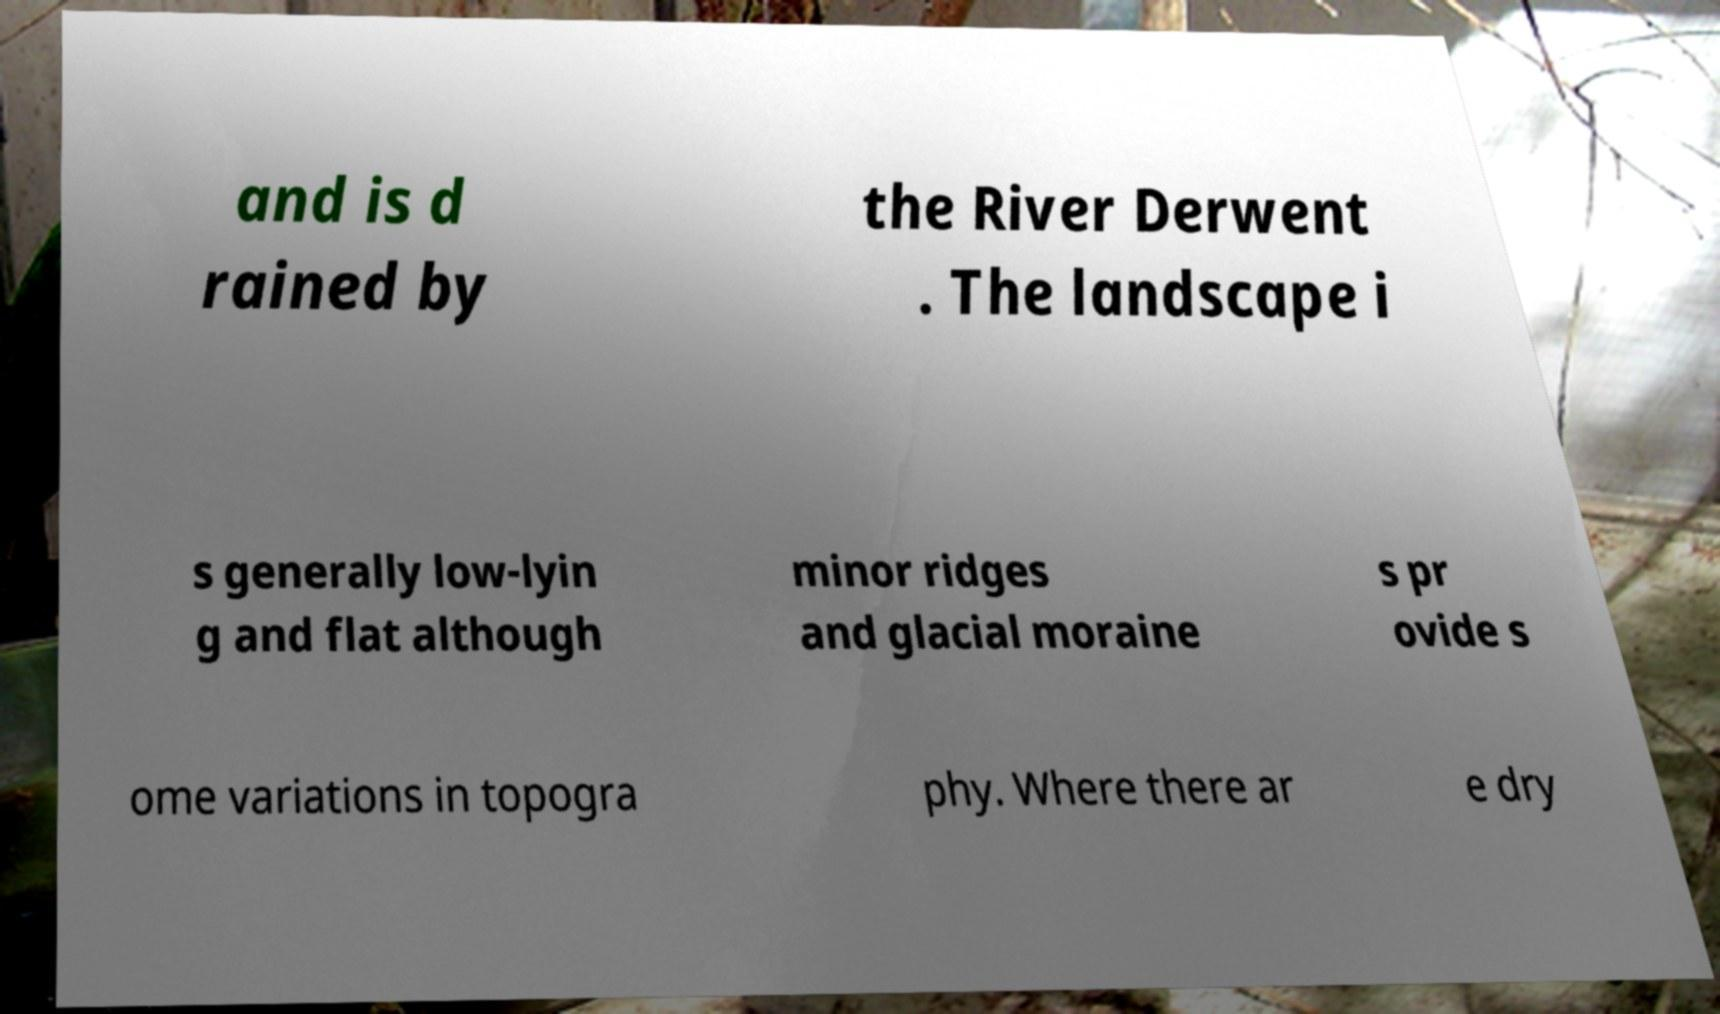I need the written content from this picture converted into text. Can you do that? and is d rained by the River Derwent . The landscape i s generally low-lyin g and flat although minor ridges and glacial moraine s pr ovide s ome variations in topogra phy. Where there ar e dry 